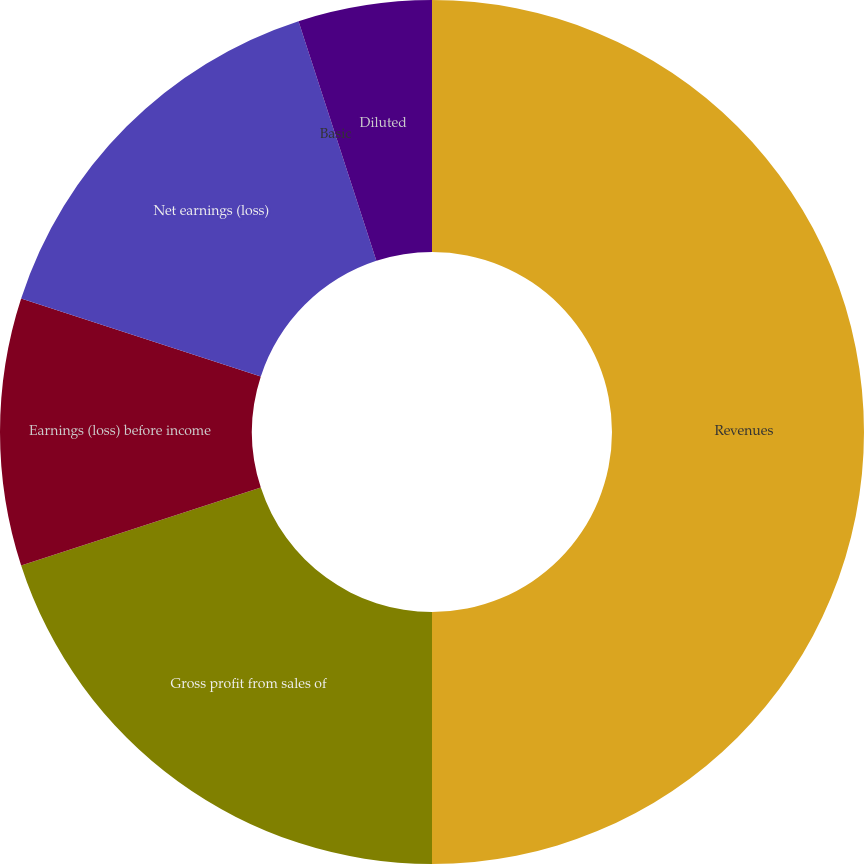Convert chart to OTSL. <chart><loc_0><loc_0><loc_500><loc_500><pie_chart><fcel>Revenues<fcel>Gross profit from sales of<fcel>Earnings (loss) before income<fcel>Net earnings (loss)<fcel>Basic<fcel>Diluted<nl><fcel>50.0%<fcel>20.0%<fcel>10.0%<fcel>15.0%<fcel>0.0%<fcel>5.0%<nl></chart> 